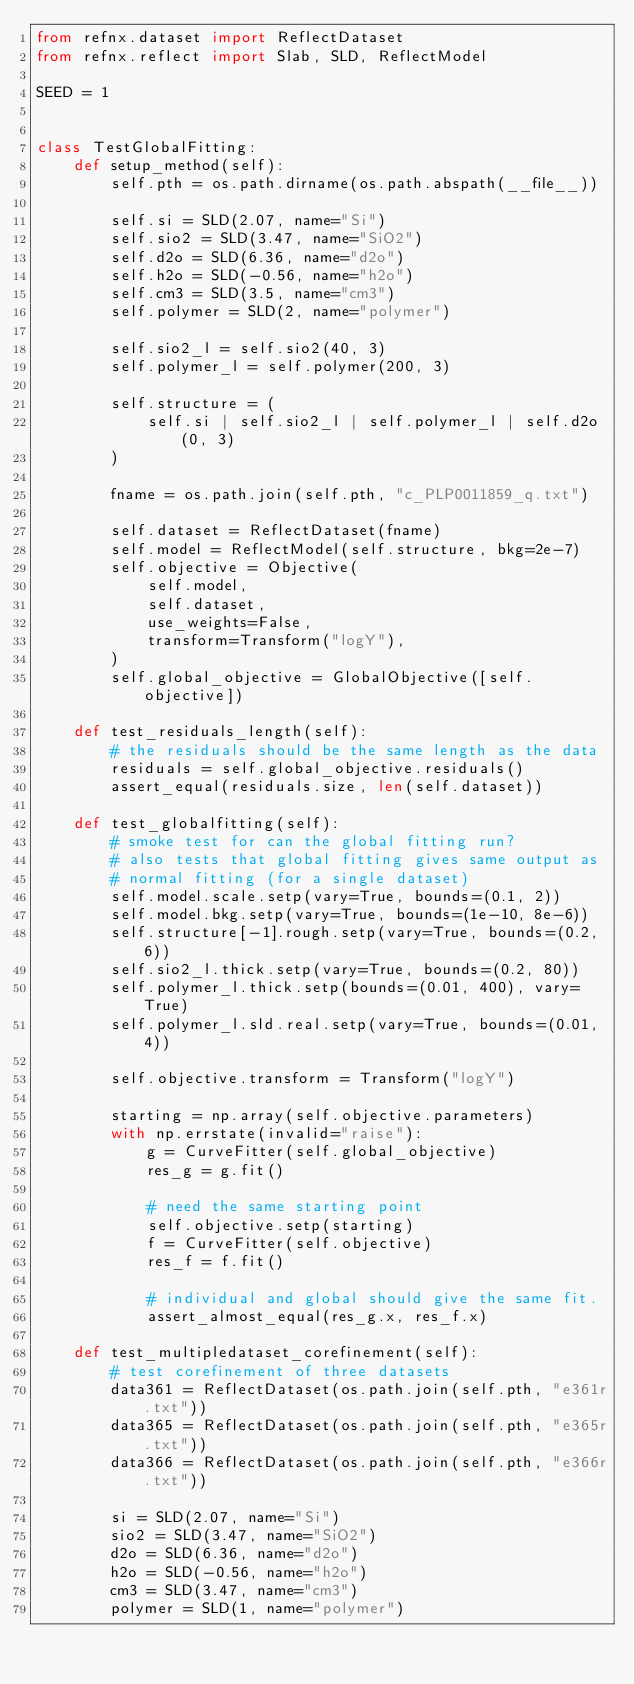<code> <loc_0><loc_0><loc_500><loc_500><_Python_>from refnx.dataset import ReflectDataset
from refnx.reflect import Slab, SLD, ReflectModel

SEED = 1


class TestGlobalFitting:
    def setup_method(self):
        self.pth = os.path.dirname(os.path.abspath(__file__))

        self.si = SLD(2.07, name="Si")
        self.sio2 = SLD(3.47, name="SiO2")
        self.d2o = SLD(6.36, name="d2o")
        self.h2o = SLD(-0.56, name="h2o")
        self.cm3 = SLD(3.5, name="cm3")
        self.polymer = SLD(2, name="polymer")

        self.sio2_l = self.sio2(40, 3)
        self.polymer_l = self.polymer(200, 3)

        self.structure = (
            self.si | self.sio2_l | self.polymer_l | self.d2o(0, 3)
        )

        fname = os.path.join(self.pth, "c_PLP0011859_q.txt")

        self.dataset = ReflectDataset(fname)
        self.model = ReflectModel(self.structure, bkg=2e-7)
        self.objective = Objective(
            self.model,
            self.dataset,
            use_weights=False,
            transform=Transform("logY"),
        )
        self.global_objective = GlobalObjective([self.objective])

    def test_residuals_length(self):
        # the residuals should be the same length as the data
        residuals = self.global_objective.residuals()
        assert_equal(residuals.size, len(self.dataset))

    def test_globalfitting(self):
        # smoke test for can the global fitting run?
        # also tests that global fitting gives same output as
        # normal fitting (for a single dataset)
        self.model.scale.setp(vary=True, bounds=(0.1, 2))
        self.model.bkg.setp(vary=True, bounds=(1e-10, 8e-6))
        self.structure[-1].rough.setp(vary=True, bounds=(0.2, 6))
        self.sio2_l.thick.setp(vary=True, bounds=(0.2, 80))
        self.polymer_l.thick.setp(bounds=(0.01, 400), vary=True)
        self.polymer_l.sld.real.setp(vary=True, bounds=(0.01, 4))

        self.objective.transform = Transform("logY")

        starting = np.array(self.objective.parameters)
        with np.errstate(invalid="raise"):
            g = CurveFitter(self.global_objective)
            res_g = g.fit()

            # need the same starting point
            self.objective.setp(starting)
            f = CurveFitter(self.objective)
            res_f = f.fit()

            # individual and global should give the same fit.
            assert_almost_equal(res_g.x, res_f.x)

    def test_multipledataset_corefinement(self):
        # test corefinement of three datasets
        data361 = ReflectDataset(os.path.join(self.pth, "e361r.txt"))
        data365 = ReflectDataset(os.path.join(self.pth, "e365r.txt"))
        data366 = ReflectDataset(os.path.join(self.pth, "e366r.txt"))

        si = SLD(2.07, name="Si")
        sio2 = SLD(3.47, name="SiO2")
        d2o = SLD(6.36, name="d2o")
        h2o = SLD(-0.56, name="h2o")
        cm3 = SLD(3.47, name="cm3")
        polymer = SLD(1, name="polymer")
</code> 